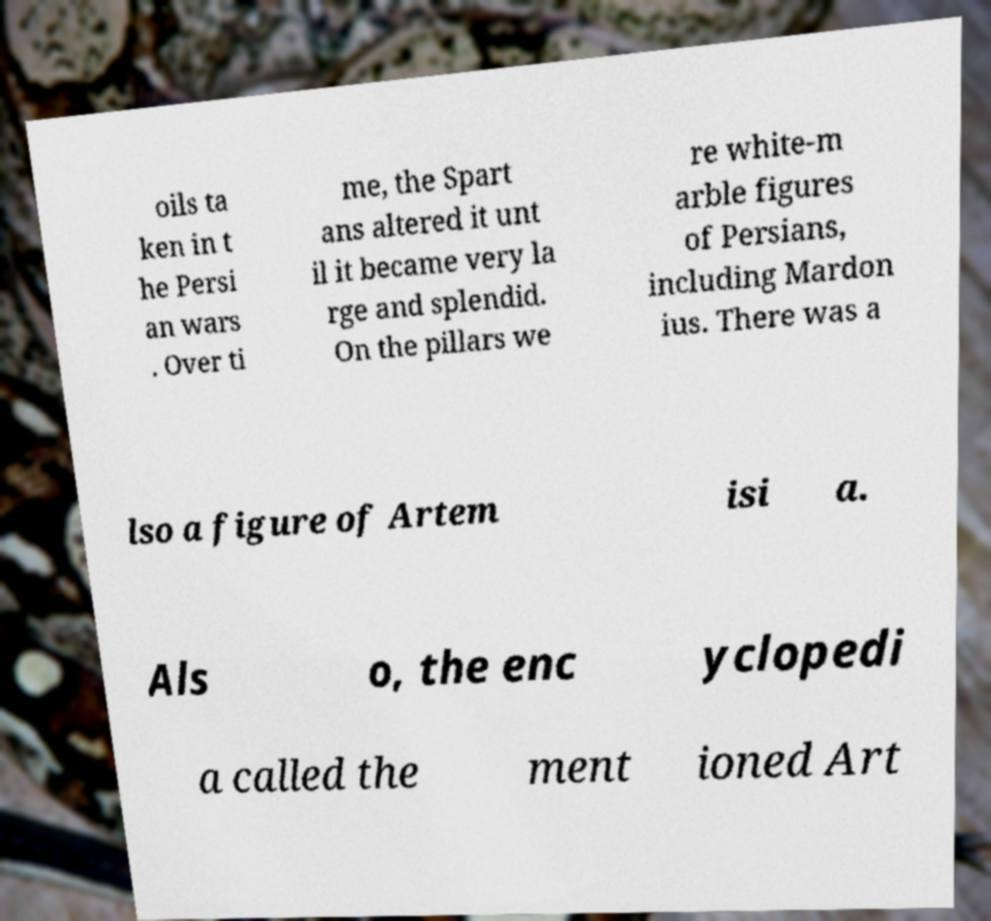Can you accurately transcribe the text from the provided image for me? oils ta ken in t he Persi an wars . Over ti me, the Spart ans altered it unt il it became very la rge and splendid. On the pillars we re white-m arble figures of Persians, including Mardon ius. There was a lso a figure of Artem isi a. Als o, the enc yclopedi a called the ment ioned Art 